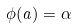Convert formula to latex. <formula><loc_0><loc_0><loc_500><loc_500>\phi ( a ) = \alpha</formula> 